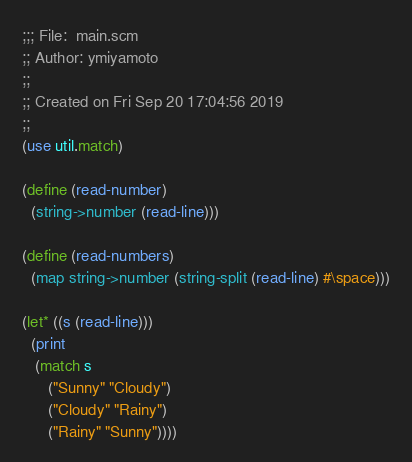Convert code to text. <code><loc_0><loc_0><loc_500><loc_500><_Scheme_>;;; File:  main.scm
;; Author: ymiyamoto
;;
;; Created on Fri Sep 20 17:04:56 2019
;;
(use util.match)

(define (read-number)
  (string->number (read-line)))

(define (read-numbers)
  (map string->number (string-split (read-line) #\space)))

(let* ((s (read-line)))
  (print
   (match s
	  ("Sunny" "Cloudy")
	  ("Cloudy" "Rainy")
	  ("Rainy" "Sunny"))))
</code> 